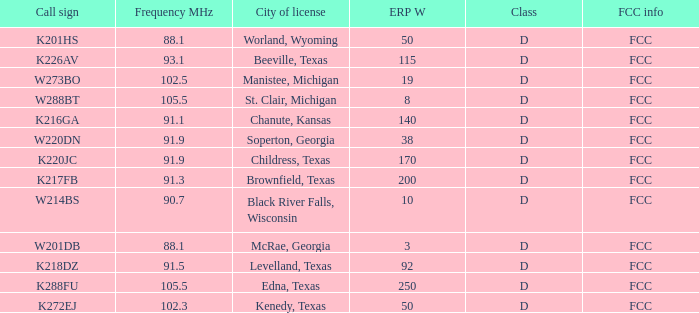What is City of License, when Frequency MHz is less than 102.5? McRae, Georgia, Soperton, Georgia, Chanute, Kansas, Beeville, Texas, Brownfield, Texas, Childress, Texas, Kenedy, Texas, Levelland, Texas, Black River Falls, Wisconsin, Worland, Wyoming. 